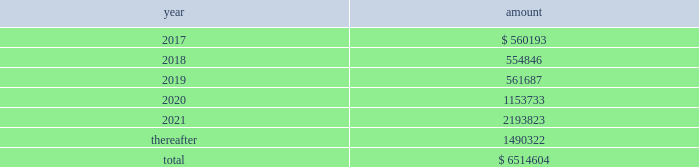New term loan a facility , with the remaining unpaid principal amount of loans under the new term loan a facility due and payable in full at maturity on june 6 , 2021 .
Principal amounts outstanding under the new revolving loan facility are due and payable in full at maturity on june 6 , 2021 , subject to earlier repayment pursuant to the springing maturity date described above .
In addition to paying interest on outstanding principal under the borrowings , we are obligated to pay a quarterly commitment fee at a rate determined by reference to a total leverage ratio , with a maximum commitment fee of 40% ( 40 % ) of the applicable margin for eurocurrency loans .
In july 2016 , breakaway four , ltd. , as borrower , and nclc , as guarantor , entered into a supplemental agreement , which amended the breakaway four loan to , among other things , increase the aggregate principal amount of commitments under the multi-draw term loan credit facility from 20ac590.5 million to 20ac729.9 million .
In june 2016 , we took delivery of seven seas explorer .
To finance the payment due upon delivery , we had export credit financing in place for 80% ( 80 % ) of the contract price .
The associated $ 373.6 million term loan bears interest at 3.43% ( 3.43 % ) with a maturity date of june 30 , 2028 .
Principal and interest payments shall be paid semiannually .
In december 2016 , nclc issued $ 700.0 million aggregate principal amount of 4.750% ( 4.750 % ) senior unsecured notes due december 2021 ( the 201cnotes 201d ) in a private offering ( the 201coffering 201d ) at par .
Nclc used the net proceeds from the offering , after deducting the initial purchasers 2019 discount and estimated fees and expenses , together with cash on hand , to purchase its outstanding 5.25% ( 5.25 % ) senior notes due 2019 having an aggregate outstanding principal amount of $ 680 million .
The redemption of the 5.25% ( 5.25 % ) senior notes due 2019 was completed in january 2017 .
Nclc will pay interest on the notes at 4.750% ( 4.750 % ) per annum , semiannually on june 15 and december 15 of each year , commencing on june 15 , 2017 , to holders of record at the close of business on the immediately preceding june 1 and december 1 , respectively .
Nclc may redeem the notes , in whole or part , at any time prior to december 15 , 2018 , at a price equal to 100% ( 100 % ) of the principal amount of the notes redeemed plus accrued and unpaid interest to , but not including , the redemption date and a 201cmake-whole premium . 201d nclc may redeem the notes , in whole or in part , on or after december 15 , 2018 , at the redemption prices set forth in the indenture governing the notes .
At any time ( which may be more than once ) on or prior to december 15 , 2018 , nclc may choose to redeem up to 40% ( 40 % ) of the aggregate principal amount of the notes at a redemption price equal to 104.750% ( 104.750 % ) of the face amount thereof with an amount equal to the net proceeds of one or more equity offerings , so long as at least 60% ( 60 % ) of the aggregate principal amount of the notes issued remains outstanding following such redemption .
The indenture governing the notes contains covenants that limit nclc 2019s ability ( and its restricted subsidiaries 2019 ability ) to , among other things : ( i ) incur or guarantee additional indebtedness or issue certain preferred shares ; ( ii ) pay dividends and make certain other restricted payments ; ( iii ) create restrictions on the payment of dividends or other distributions to nclc from its restricted subsidiaries ; ( iv ) create liens on certain assets to secure debt ; ( v ) make certain investments ; ( vi ) engage in transactions with affiliates ; ( vii ) engage in sales of assets and subsidiary stock ; and ( viii ) transfer all or substantially all of its assets or enter into merger or consolidation transactions .
The indenture governing the notes also provides for events of default , which , if any of them occurs , would permit or require the principal , premium ( if any ) , interest and other monetary obligations on all of the then-outstanding notes to become due and payable immediately .
Interest expense , net for the year ended december 31 , 2016 was $ 276.9 million which included $ 34.7 million of amortization of deferred financing fees and a $ 27.7 million loss on extinguishment of debt .
Interest expense , net for the year ended december 31 , 2015 was $ 221.9 million which included $ 36.7 million of amortization of deferred financing fees and a $ 12.7 million loss on extinguishment of debt .
Interest expense , net for the year ended december 31 , 2014 was $ 151.8 million which included $ 32.3 million of amortization of deferred financing fees and $ 15.4 million of expenses related to financing transactions in connection with the acquisition of prestige .
Certain of our debt agreements contain covenants that , among other things , require us to maintain a minimum level of liquidity , as well as limit our net funded debt-to-capital ratio , maintain certain other ratios and restrict our ability to pay dividends .
Substantially all of our ships and other property and equipment are pledged as collateral for certain of our debt .
We believe we were in compliance with these covenants as of december 31 , 2016 .
The following are scheduled principal repayments on long-term debt including capital lease obligations as of december 31 , 2016 for each of the next five years ( in thousands ) : .
We had an accrued interest liability of $ 32.5 million and $ 34.2 million as of december 31 , 2016 and 2015 , respectively. .
In december 2016 the nclc issued senior unsecured notes due december 2021 , what is the payment they will receive on december 2021? 
Rationale: to find the total amount the company will be paid , one has to multiple the initial loan by the amount of interest and then add the interest to the initial amount .
Computations: ((700.0 * 4.750%) + 700.0)
Answer: 733.25. 